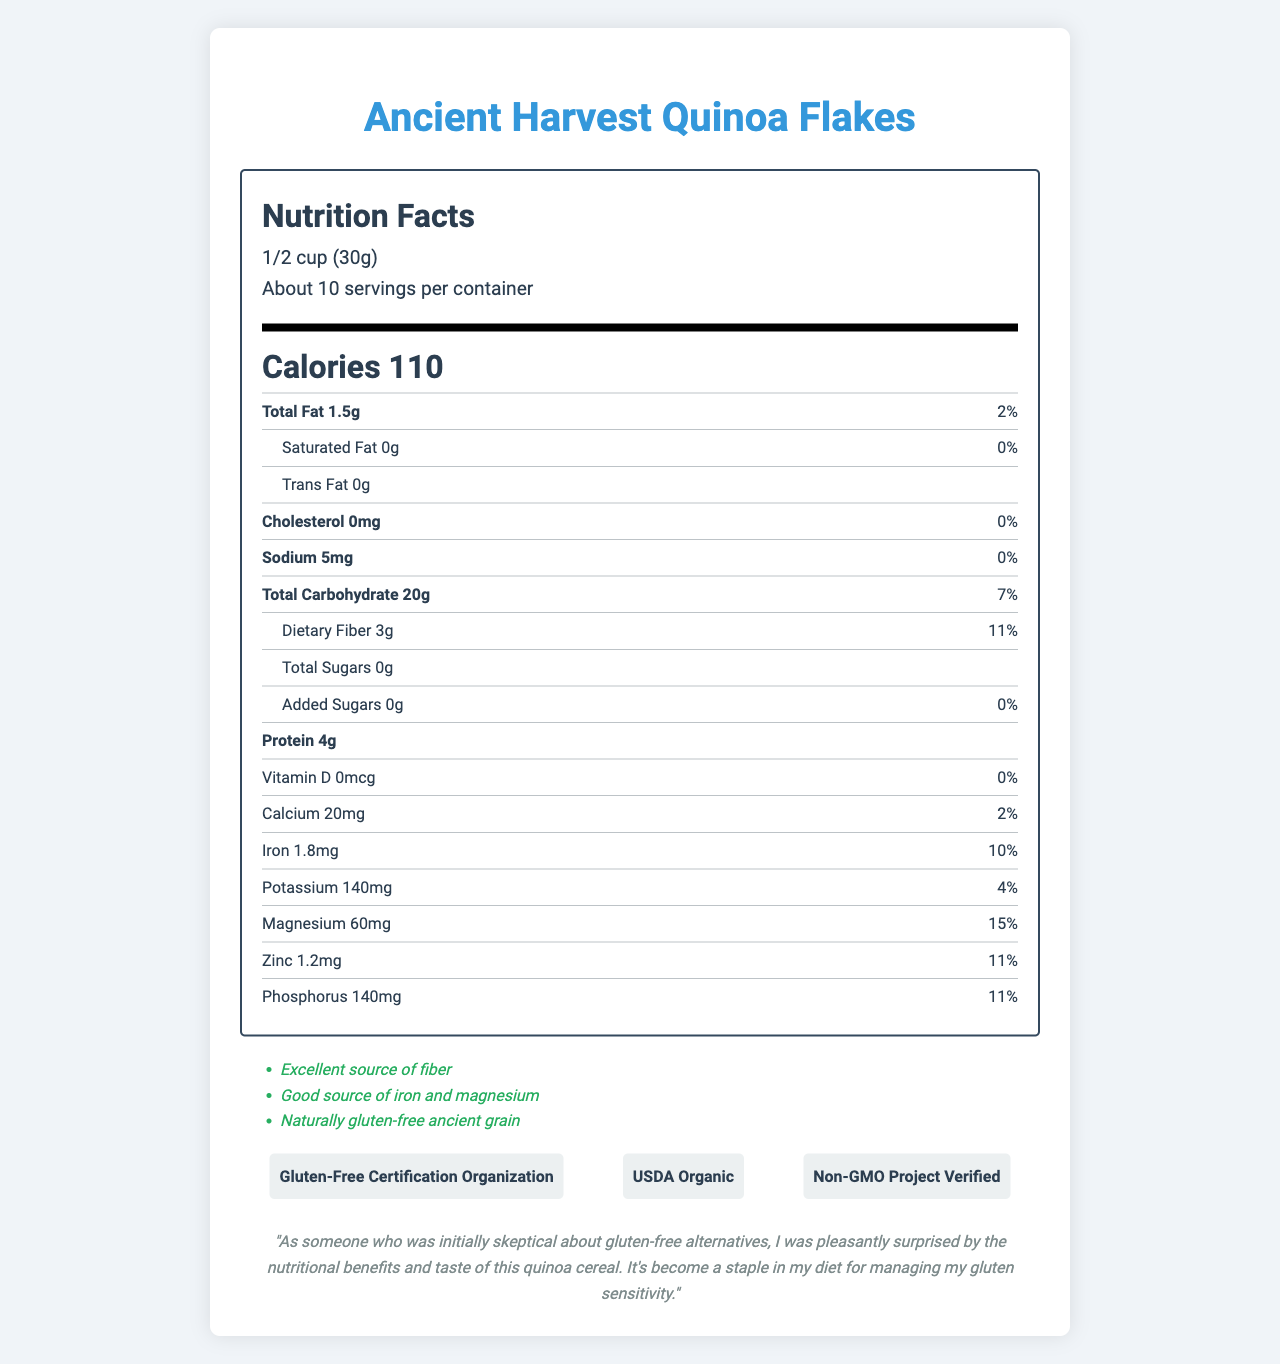what is the serving size of the cereal? The serving size is listed at the top of the Nutrition Facts label as "1/2 cup (30g)".
Answer: 1/2 cup (30g) how many servings are in the container? The document states "Servings Per Container: About 10" under the serving size.
Answer: About 10 what is the amount of dietary fiber per serving? The nutrient row for dietary fiber says "Dietary Fiber 3g".
Answer: 3g how many calories are in one serving of this cereal? The large, bold text in the middle of the label indicates that each serving contains 110 calories.
Answer: 110 calories what percentage of the daily value for magnesium does one serving provide? The nutrient row for magnesium lists "Magnesium 60mg" with a percent daily value of 15%.
Answer: 15% which of the following certifications does the product have? A. USDA Organic B. Non-GMO Project Verified C. Gluten-Free Certification Organization D. All of the above The certifications listed at the bottom indicate that the product is USDA Organic, Non-GMO Project Verified, and has the Gluten-Free Certification Organization certification.
Answer: D. All of the above which micronutrient has the highest percent daily value per serving? A. Calcium B. Zinc C. Magnesium D. Iron The document shows that magnesium has a percent daily value of 15%, which is the highest compared to other listed micronutrients.
Answer: C. Magnesium is this cereal gluten-free? The document has a "Certified Gluten-Free" label indicating that the cereal is gluten-free.
Answer: Yes summarize the document in a few sentences. The summary encapsulates all key points from the nutritional values, serving information, certifications, and health claims.
Answer: The document is a Nutrition Facts label for Ancient Harvest Quinoa Flakes, a gluten-free cereal made from organic quinoa flakes. It highlights nutritional information such as 110 calories per serving, 3g of dietary fiber, and key micronutrients like iron (10% DV) and magnesium (15% DV). The product is certified gluten-free, organic, and non-GMO. Additional health claims include being an excellent source of fiber and a good source of iron and magnesium. what is the main ingredient of the cereal? The ingredients section lists "Organic quinoa flakes" as the sole ingredient.
Answer: Organic quinoa flakes how should the product be stored? The storage instructions specify to "Store in a cool, dry place".
Answer: Store in a cool, dry place does the product contain any added sugars? The document states "Added Sugars 0g" with a percent daily value of 0%.
Answer: No how much protein is in one serving of the cereal? The nutrient row for protein lists "Protein 4g".
Answer: 4g can you tell me how this cereal tastes? The document does not provide any information regarding the taste of the cereal. It only provides nutritional information and certifications.
Answer: I don't know 